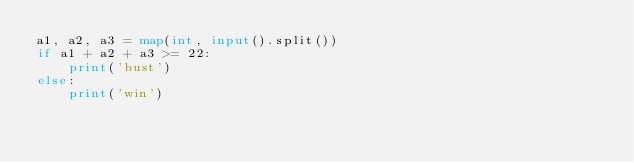<code> <loc_0><loc_0><loc_500><loc_500><_Python_>a1, a2, a3 = map(int, input().split())
if a1 + a2 + a3 >= 22:
    print('bust')
else:
    print('win')
</code> 